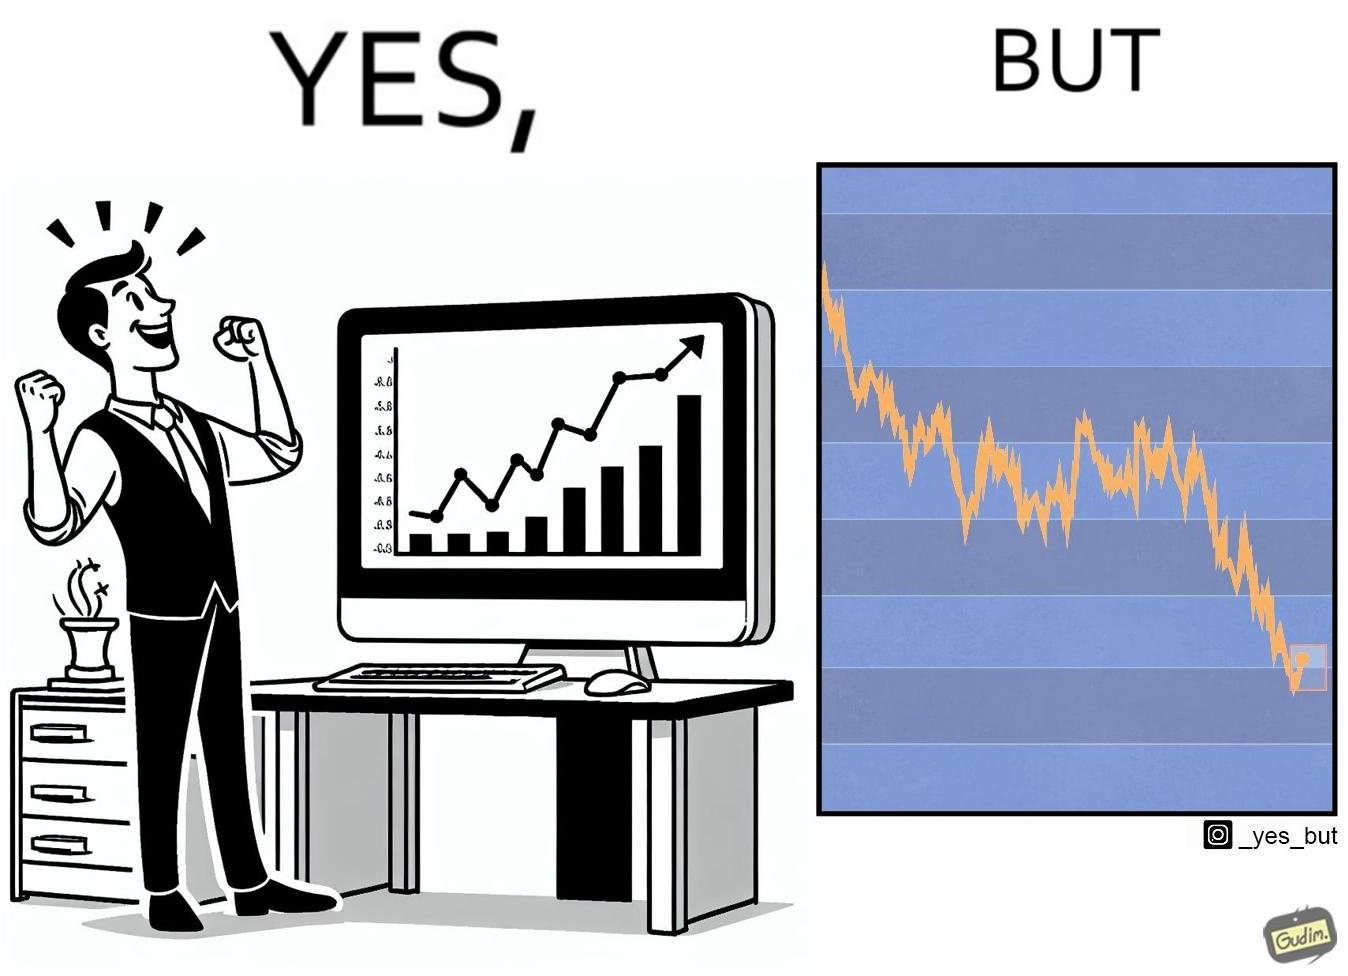What do you see in each half of this image? In the left part of the image: a person feeling proud after looking at the profit in his stocks investment In the right part of the image: a graph representing loss in some stocks 